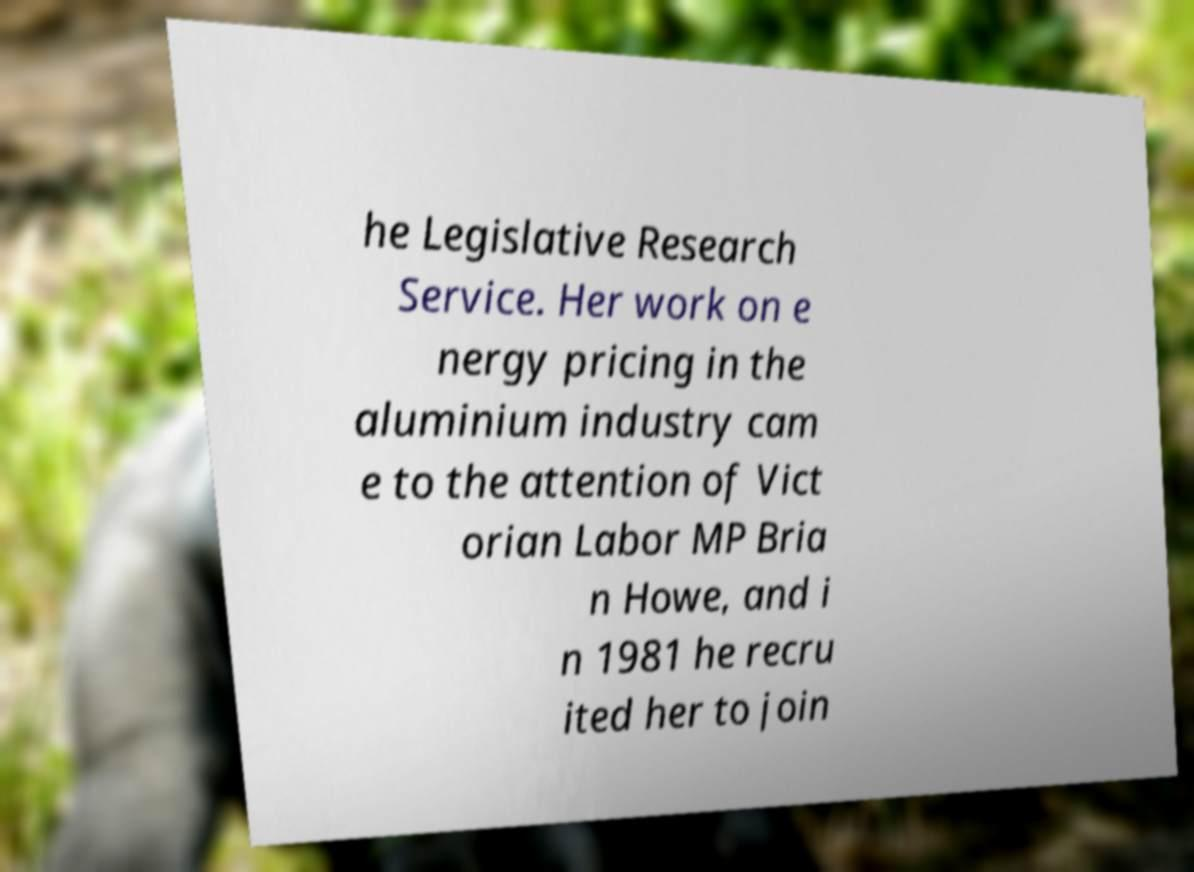Could you extract and type out the text from this image? he Legislative Research Service. Her work on e nergy pricing in the aluminium industry cam e to the attention of Vict orian Labor MP Bria n Howe, and i n 1981 he recru ited her to join 